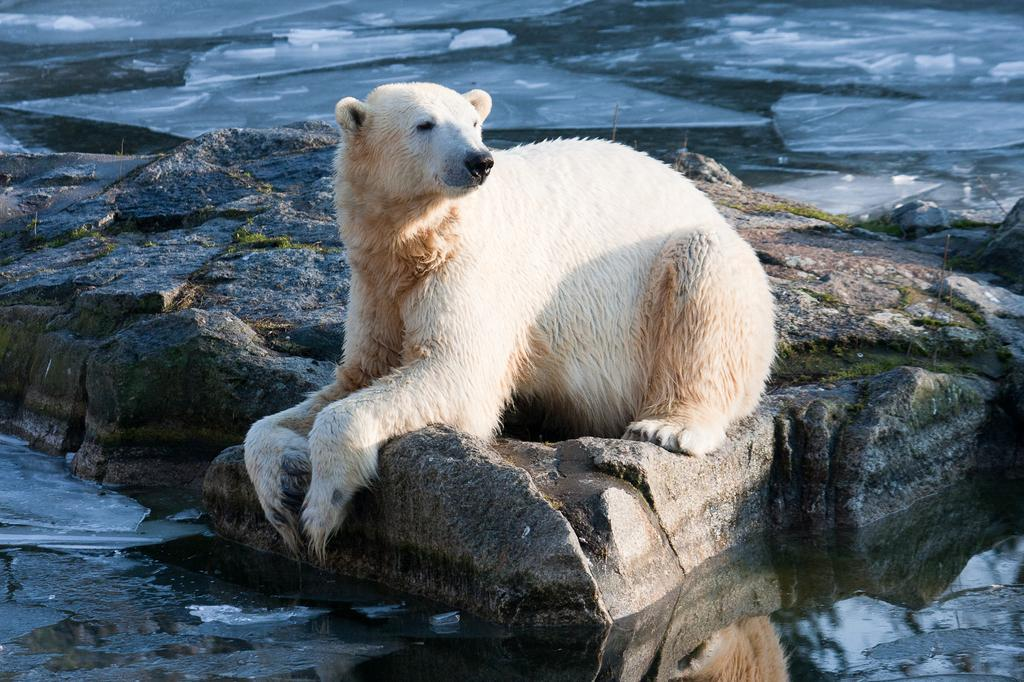What animal is the main subject of the image? There is a polar bear in the image. What is the polar bear sitting on? The polar bear is sitting on rocks. Where is the polar bear located in the image? The polar bear is in the foreground of the image. What type of furniture can be seen in the image? There is no furniture present in the image; it features a polar bear sitting on rocks. What month is depicted on the calendar in the image? There is no calendar present in the image. 